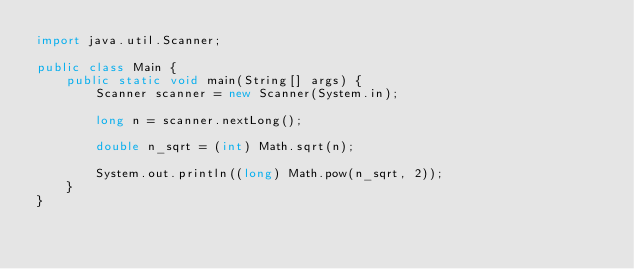Convert code to text. <code><loc_0><loc_0><loc_500><loc_500><_Java_>import java.util.Scanner;

public class Main {
    public static void main(String[] args) {
        Scanner scanner = new Scanner(System.in);

        long n = scanner.nextLong();

        double n_sqrt = (int) Math.sqrt(n);

        System.out.println((long) Math.pow(n_sqrt, 2));
    }
}</code> 